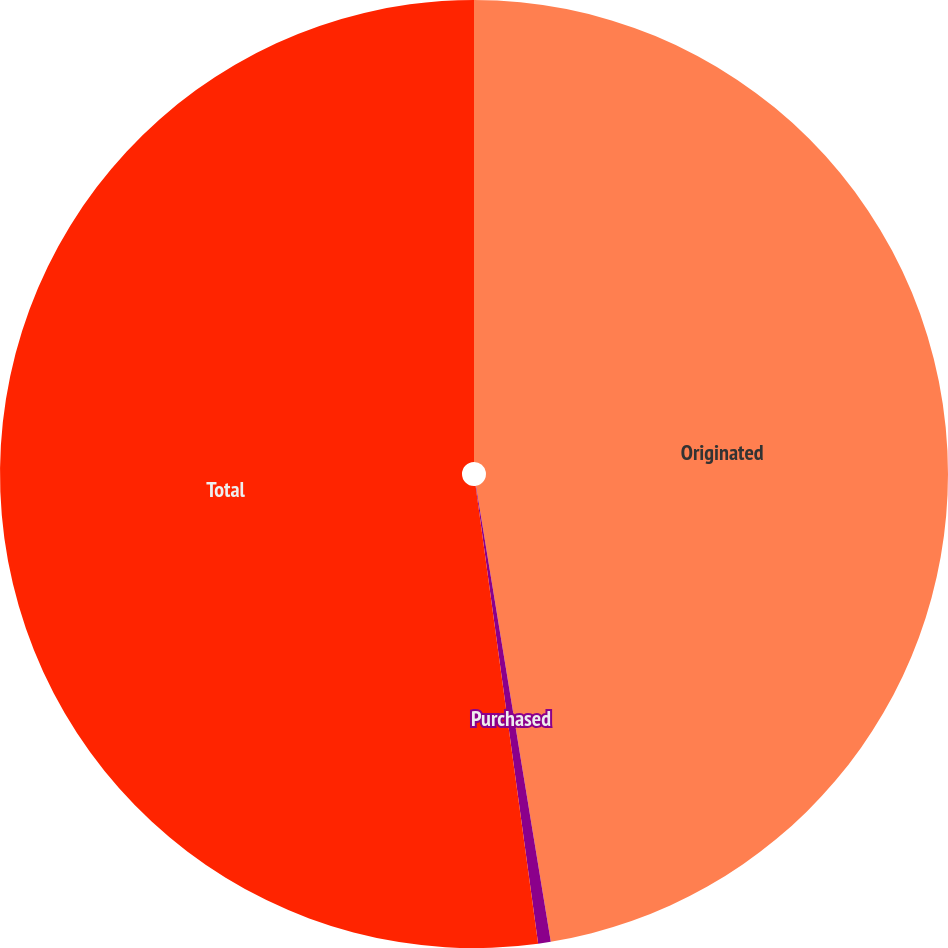Convert chart to OTSL. <chart><loc_0><loc_0><loc_500><loc_500><pie_chart><fcel>Originated<fcel>Purchased<fcel>Total<nl><fcel>47.41%<fcel>0.43%<fcel>52.16%<nl></chart> 